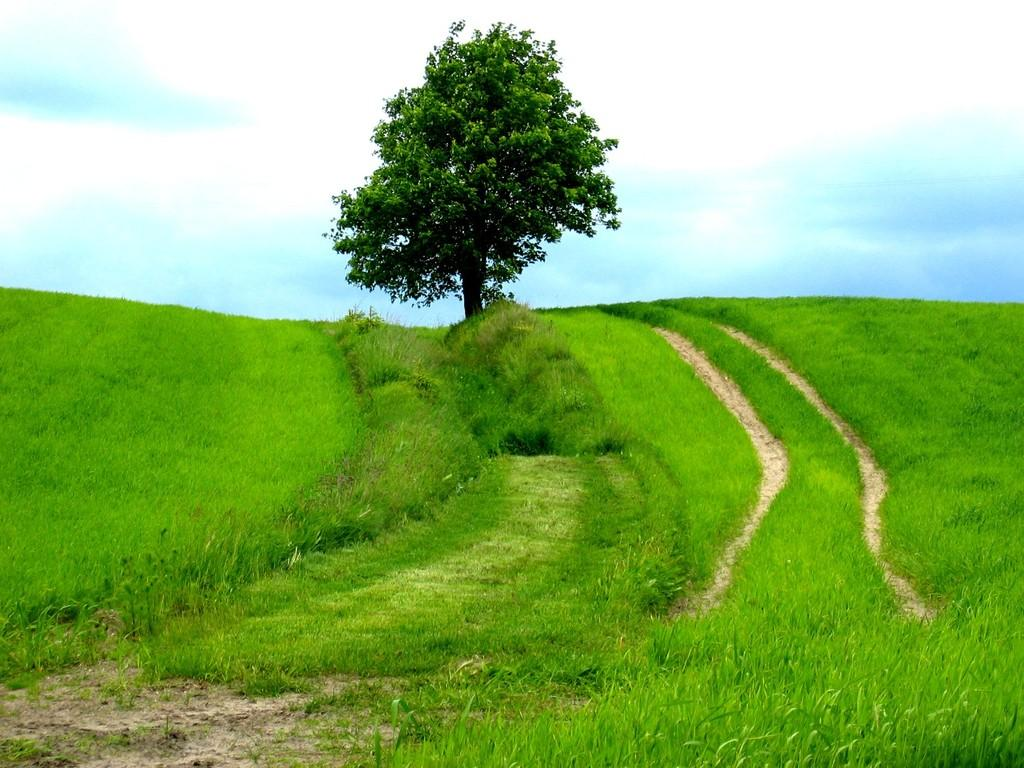What type of surface is visible in the image? There is ground visible in the image. What is covering the ground? There is grass on the ground, which is green in color. What other natural element can be seen in the image? There is a tree in the image. What is visible in the distance in the image? The sky is visible in the background of the image. What type of magic is being performed by the tree in the image? There is no magic being performed by the tree in the image; it is a natural element in the scene. What is the tendency of the underwear in the image? There is no underwear present in the image, so it is not possible to determine its tendency. 